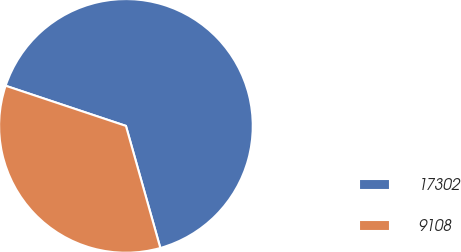Convert chart to OTSL. <chart><loc_0><loc_0><loc_500><loc_500><pie_chart><fcel>17302<fcel>9108<nl><fcel>65.5%<fcel>34.5%<nl></chart> 